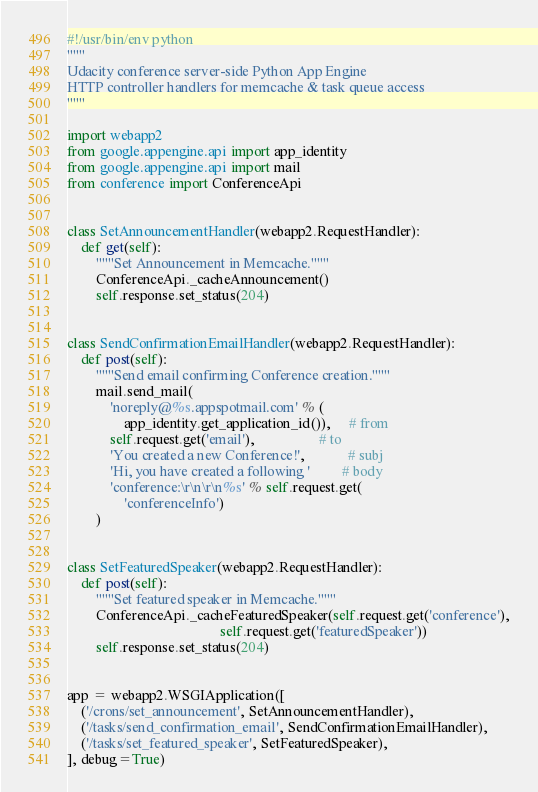<code> <loc_0><loc_0><loc_500><loc_500><_Python_>#!/usr/bin/env python
"""
Udacity conference server-side Python App Engine
HTTP controller handlers for memcache & task queue access
"""

import webapp2
from google.appengine.api import app_identity
from google.appengine.api import mail
from conference import ConferenceApi


class SetAnnouncementHandler(webapp2.RequestHandler):
    def get(self):
        """Set Announcement in Memcache."""
        ConferenceApi._cacheAnnouncement()
        self.response.set_status(204)


class SendConfirmationEmailHandler(webapp2.RequestHandler):
    def post(self):
        """Send email confirming Conference creation."""
        mail.send_mail(
            'noreply@%s.appspotmail.com' % (
                app_identity.get_application_id()),     # from
            self.request.get('email'),                  # to
            'You created a new Conference!',            # subj
            'Hi, you have created a following '         # body
            'conference:\r\n\r\n%s' % self.request.get(
                'conferenceInfo')
        )


class SetFeaturedSpeaker(webapp2.RequestHandler):
    def post(self):
        """Set featured speaker in Memcache."""
        ConferenceApi._cacheFeaturedSpeaker(self.request.get('conference'),
                                           self.request.get('featuredSpeaker'))
        self.response.set_status(204)


app = webapp2.WSGIApplication([
    ('/crons/set_announcement', SetAnnouncementHandler),
    ('/tasks/send_confirmation_email', SendConfirmationEmailHandler),
    ('/tasks/set_featured_speaker', SetFeaturedSpeaker),
], debug=True)
</code> 